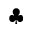<formula> <loc_0><loc_0><loc_500><loc_500>\clubsuit</formula> 